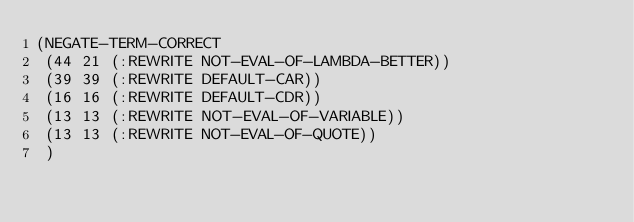<code> <loc_0><loc_0><loc_500><loc_500><_Lisp_>(NEGATE-TERM-CORRECT
 (44 21 (:REWRITE NOT-EVAL-OF-LAMBDA-BETTER))
 (39 39 (:REWRITE DEFAULT-CAR))
 (16 16 (:REWRITE DEFAULT-CDR))
 (13 13 (:REWRITE NOT-EVAL-OF-VARIABLE))
 (13 13 (:REWRITE NOT-EVAL-OF-QUOTE))
 )
</code> 